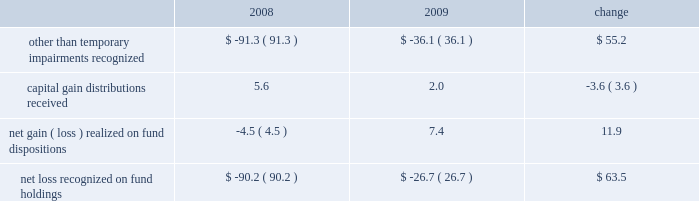Our non-operating investment activity resulted in net losses of $ 12.7 million in 2009 and $ 52.3 million in 2008 .
The improvement of nearly $ 40 million is primarily attributable to a reduction in the other than temporary impairments recognized on our investments in sponsored mutual funds in 2009 versus 2008 .
The table details our related mutual fund investment gains and losses ( in millions ) during the past two years. .
Lower income of $ 16 million from our money market holdings due to the significantly lower interest rate environment offset the improvement experienced with our fund investments .
There is no impairment of any of our mutual fund investments at december 31 , 2009 .
The 2009 provision for income taxes as a percentage of pretax income is 37.1% ( 37.1 % ) , down from 38.4% ( 38.4 % ) in 2008 and .9% ( .9 % ) lower than our present estimate of 38.0% ( 38.0 % ) for the 2010 effective tax rate .
Our 2009 provision includes reductions of prior years 2019 tax provisions and discrete nonrecurring benefits that lowered our 2009 effective tax rate by 1.0% ( 1.0 % ) .
2008 versus 2007 .
Investment advisory revenues decreased 6.3% ( 6.3 % ) , or $ 118 million , to $ 1.76 billion in 2008 as average assets under our management decreased $ 16 billion to $ 358.2 billion .
The average annualized fee rate earned on our assets under management was 49.2 basis points in 2008 , down from the 50.2 basis points earned in 2007 , as lower equity market valuations resulted in a greater percentage of our assets under management being attributable to lower fee fixed income portfolios .
Continuing stress on the financial markets and resulting lower equity valuations as 2008 progressed resulted in lower average assets under our management , lower investment advisory fees and lower net income as compared to prior periods .
Net revenues decreased 5% ( 5 % ) , or $ 112 million , to $ 2.12 billion .
Operating expenses were $ 1.27 billion in 2008 , up 2.9% ( 2.9 % ) or $ 36 million from 2007 .
Net operating income for 2008 decreased $ 147.9 million , or 14.8% ( 14.8 % ) , to $ 848.5 million .
Higher operating expenses in 2008 and decreased market valuations during the latter half of 2008 , which lowered our assets under management and advisory revenues , resulted in our 2008 operating margin declining to 40.1% ( 40.1 % ) from 44.7% ( 44.7 % ) in 2007 .
Non-operating investment losses in 2008 were $ 52.3 million as compared to investment income of $ 80.4 million in 2007 .
Investment losses in 2008 include non-cash charges of $ 91.3 million for the other than temporary impairment of certain of the firm 2019s investments in sponsored mutual funds .
Net income in 2008 fell 27% ( 27 % ) or nearly $ 180 million from 2007 .
Diluted earnings per share , after the retrospective application of new accounting guidance effective in 2009 , decreased to $ 1.81 , down $ .59 or 24.6% ( 24.6 % ) from $ 2.40 in 2007 .
A non-operating charge to recognize other than temporary impairments of our sponsored mutual fund investments reduced diluted earnings per share by $ .21 in 2008 .
Investment advisory revenues earned from the t .
Rowe price mutual funds distributed in the united states decreased 8.5% ( 8.5 % ) , or $ 114.5 million , to $ 1.24 billion .
Average mutual fund assets were $ 216.1 billion in 2008 , down $ 16.7 billion from 2007 .
Mutual fund assets at december 31 , 2008 , were $ 164.4 billion , down $ 81.6 billion from the end of 2007 .
Net inflows to the mutual funds during 2008 were $ 3.9 billion , including $ 1.9 billion to the money funds , $ 1.1 billion to the bond funds , and $ .9 billion to the stock funds .
The value , equity index 500 , and emerging markets stock funds combined to add $ 4.1 billion , while the mid-cap growth and equity income stock funds had net redemptions of $ 2.2 billion .
Net fund inflows of $ 6.2 billion originated in our target-date retirement funds , which in turn invest in other t .
Rowe price funds .
Fund net inflow amounts in 2008 are presented net of $ 1.3 billion that was transferred to target-date trusts from the retirement funds during the year .
Decreases in market valuations and income not reinvested lowered our mutual fund assets under management by $ 85.5 billion during 2008 .
Investment advisory revenues earned on the other investment portfolios that we manage decreased $ 3.6 million to $ 522.2 million .
Average assets in these portfolios were $ 142.1 billion during 2008 , up slightly from $ 141.4 billion in 2007 .
These minor changes , each less than 1% ( 1 % ) , are attributable to the timing of declining equity market valuations and cash flows among our separate account and subadvised portfolios .
Net inflows , primarily from institutional investors , were $ 13.2 billion during 2008 , including the $ 1.3 billion transferred from the retirement funds to target-date trusts .
Decreases in market valuations , net of income , lowered our assets under management in these portfolios by $ 55.3 billion during 2008 .
Management 2019s discussion & analysis 21 .
What percentage of the net inflows primarily from institutional investors was due to the transfer from retirement funds to target-date trusts? 
Computations: (1.3 / 13.2)
Answer: 0.09848. 